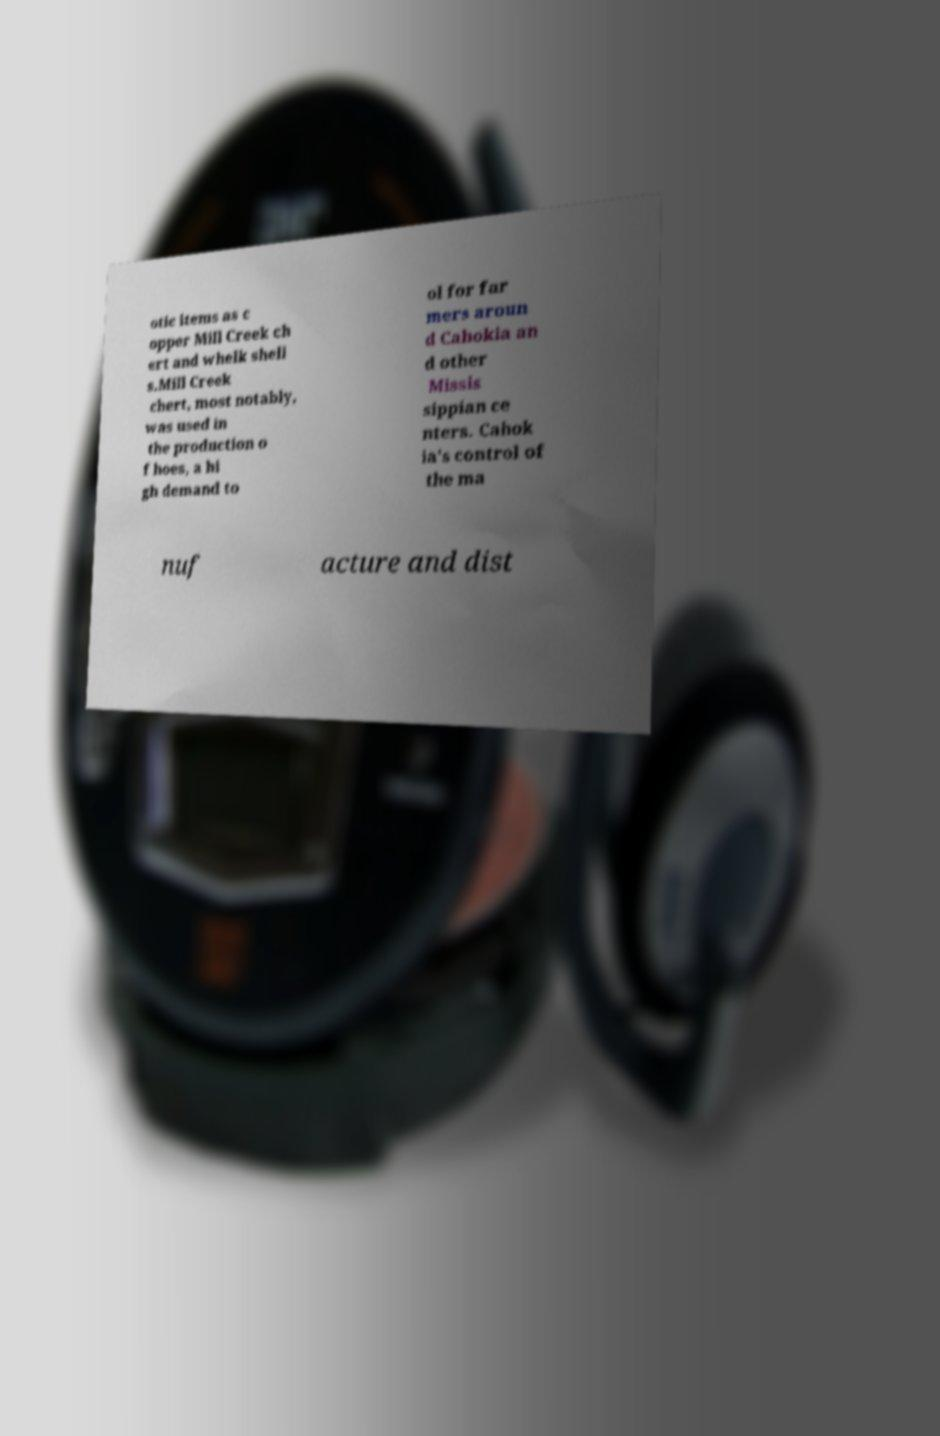Please identify and transcribe the text found in this image. otic items as c opper Mill Creek ch ert and whelk shell s.Mill Creek chert, most notably, was used in the production o f hoes, a hi gh demand to ol for far mers aroun d Cahokia an d other Missis sippian ce nters. Cahok ia's control of the ma nuf acture and dist 